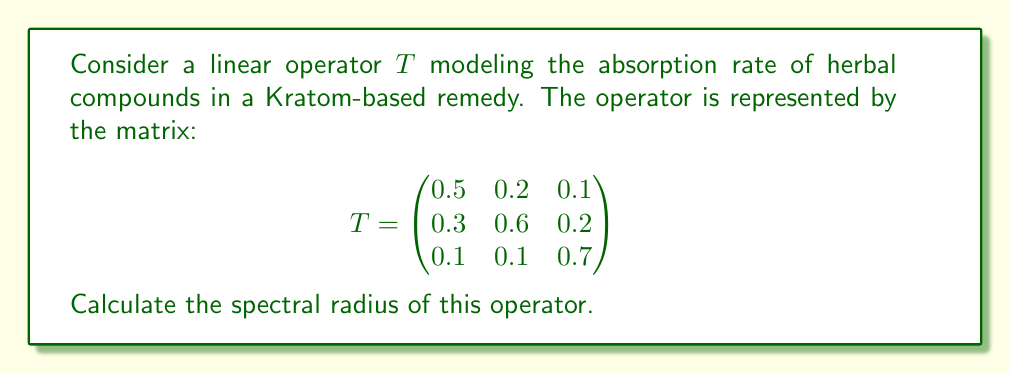Help me with this question. To find the spectral radius of the operator $T$, we need to follow these steps:

1) First, we need to find the eigenvalues of $T$. The characteristic equation is:

   $$\det(T - \lambda I) = 0$$

2) Expanding this determinant:

   $$\begin{vmatrix}
   0.5-\lambda & 0.2 & 0.1 \\
   0.3 & 0.6-\lambda & 0.2 \\
   0.1 & 0.1 & 0.7-\lambda
   \end{vmatrix} = 0$$

3) This yields the cubic equation:

   $$-\lambda^3 + 1.8\lambda^2 - 0.97\lambda + 0.156 = 0$$

4) Solving this equation (using a computer algebra system or numerical methods), we get the eigenvalues:

   $$\lambda_1 \approx 0.9023, \lambda_2 \approx 0.4988, \lambda_3 \approx 0.3989$$

5) The spectral radius $\rho(T)$ is defined as the maximum of the absolute values of the eigenvalues:

   $$\rho(T) = \max\{|\lambda_1|, |\lambda_2|, |\lambda_3|\}$$

6) In this case, the largest absolute value is $|\lambda_1| \approx 0.9023$.

Therefore, the spectral radius of the operator $T$ is approximately 0.9023.
Answer: $\rho(T) \approx 0.9023$ 